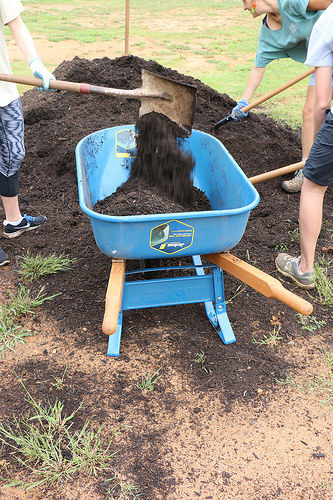<image>
Can you confirm if the soil is in the wheelbarrow? Yes. The soil is contained within or inside the wheelbarrow, showing a containment relationship. Is there a shovel in the barrel? No. The shovel is not contained within the barrel. These objects have a different spatial relationship. 